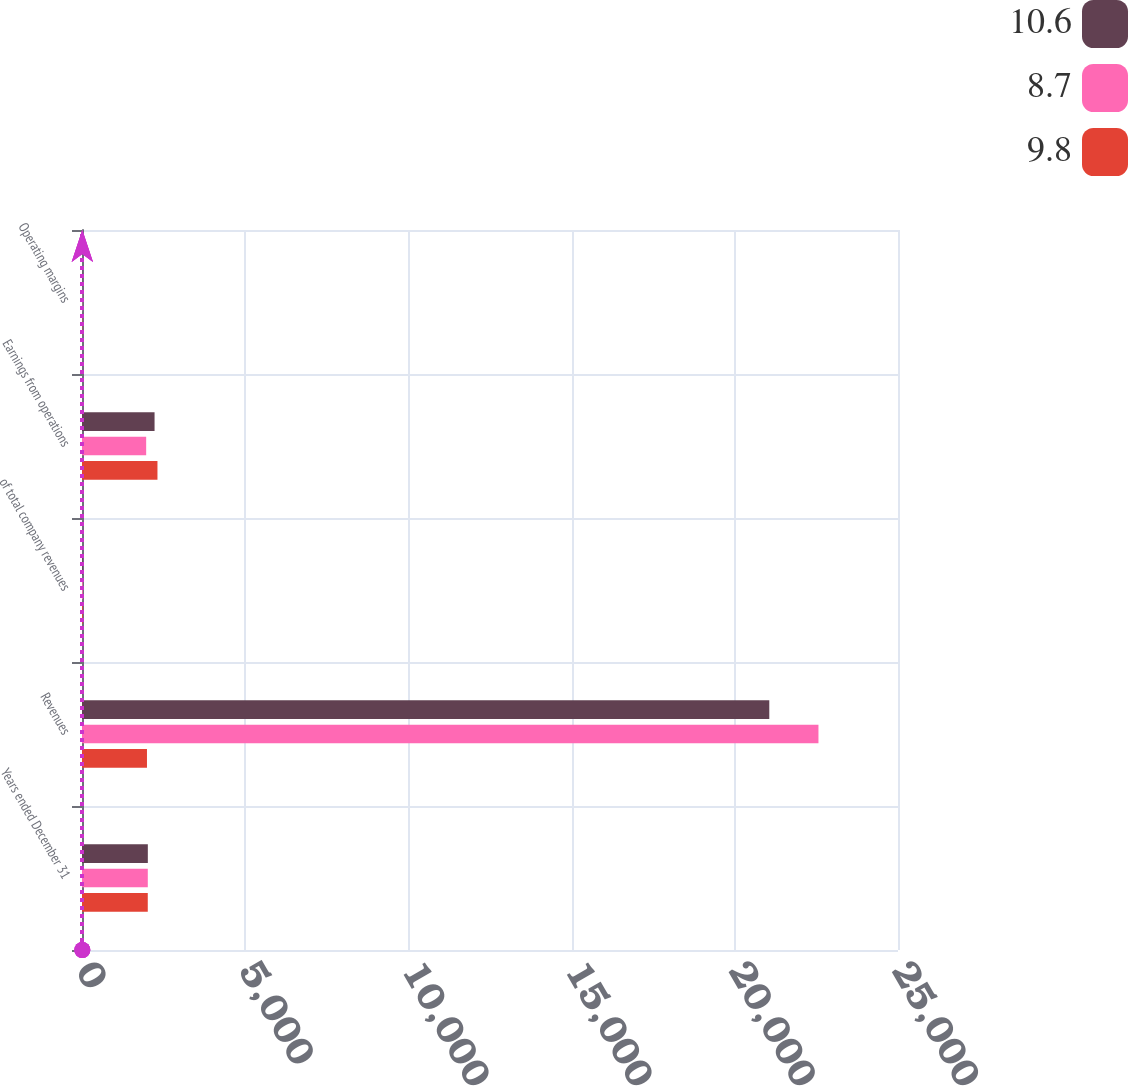Convert chart to OTSL. <chart><loc_0><loc_0><loc_500><loc_500><stacked_bar_chart><ecel><fcel>Years ended December 31<fcel>Revenues<fcel>of total company revenues<fcel>Earnings from operations<fcel>Operating margins<nl><fcel>10.6<fcel>2017<fcel>21057<fcel>23<fcel>2223<fcel>10.6<nl><fcel>8.7<fcel>2016<fcel>22563<fcel>24<fcel>1966<fcel>8.7<nl><fcel>9.8<fcel>2015<fcel>1990.5<fcel>25<fcel>2312<fcel>9.8<nl></chart> 